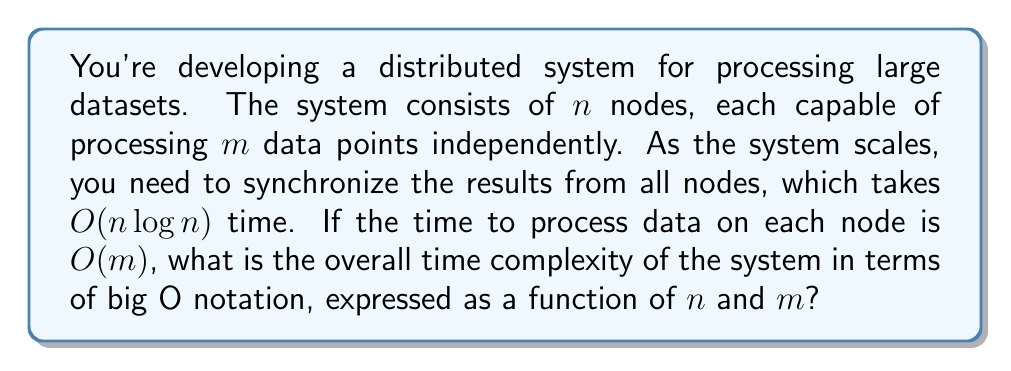Give your solution to this math problem. To determine the overall time complexity, we need to consider both the processing time on individual nodes and the synchronization time across all nodes:

1. Processing time on each node:
   - Each node processes $m$ data points
   - Time complexity for processing on each node: $O(m)$

2. Synchronization time across all nodes:
   - Given as $O(n \log n)$

3. Total time complexity:
   - The system first processes data on all nodes in parallel, then synchronizes the results
   - Parallel processing time is determined by the slowest node, which is still $O(m)$
   - After processing, synchronization takes $O(n \log n)$
   - Total time is the sum of these two steps: $O(m) + O(n \log n)$

4. Simplifying the expression:
   - We can't combine $O(m)$ and $O(n \log n)$ further without knowing the relative sizes of $m$ and $n$
   - The correct way to express this is to keep both terms: $O(m + n \log n)$

This expression, $O(m + n \log n)$, accurately represents the scalability of the system, showing how it depends on both the amount of data processed per node $(m)$ and the number of nodes $(n)$.
Answer: $O(m + n \log n)$ 